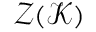Convert formula to latex. <formula><loc_0><loc_0><loc_500><loc_500>\mathcal { Z } ( \mathcal { K } )</formula> 